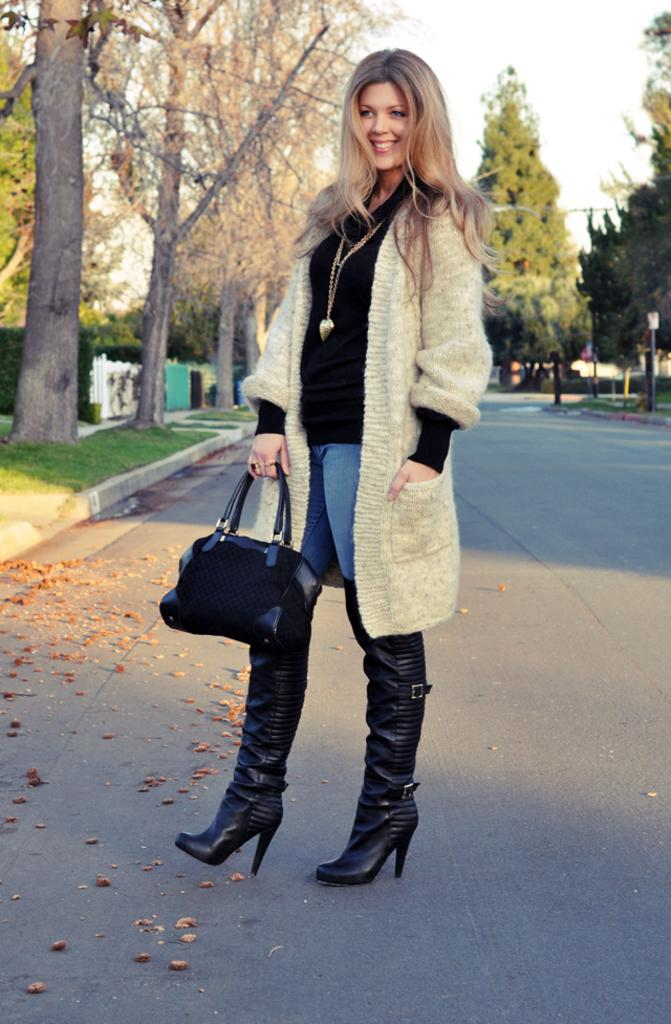Who is the main subject in the image? There is a woman in the image. What is the woman holding in the image? The woman is holding a black bag. What is the woman's facial expression in the image? The woman is standing and smiling. What can be seen in the background of the image? There are trees in the background of the image. How many buttons are visible on the woman's shirt in the image? There is no information about buttons on the woman's shirt in the image. What type of sugar is being used to sweeten the woman's drink in the image? There is no drink or sugar present in the image. 